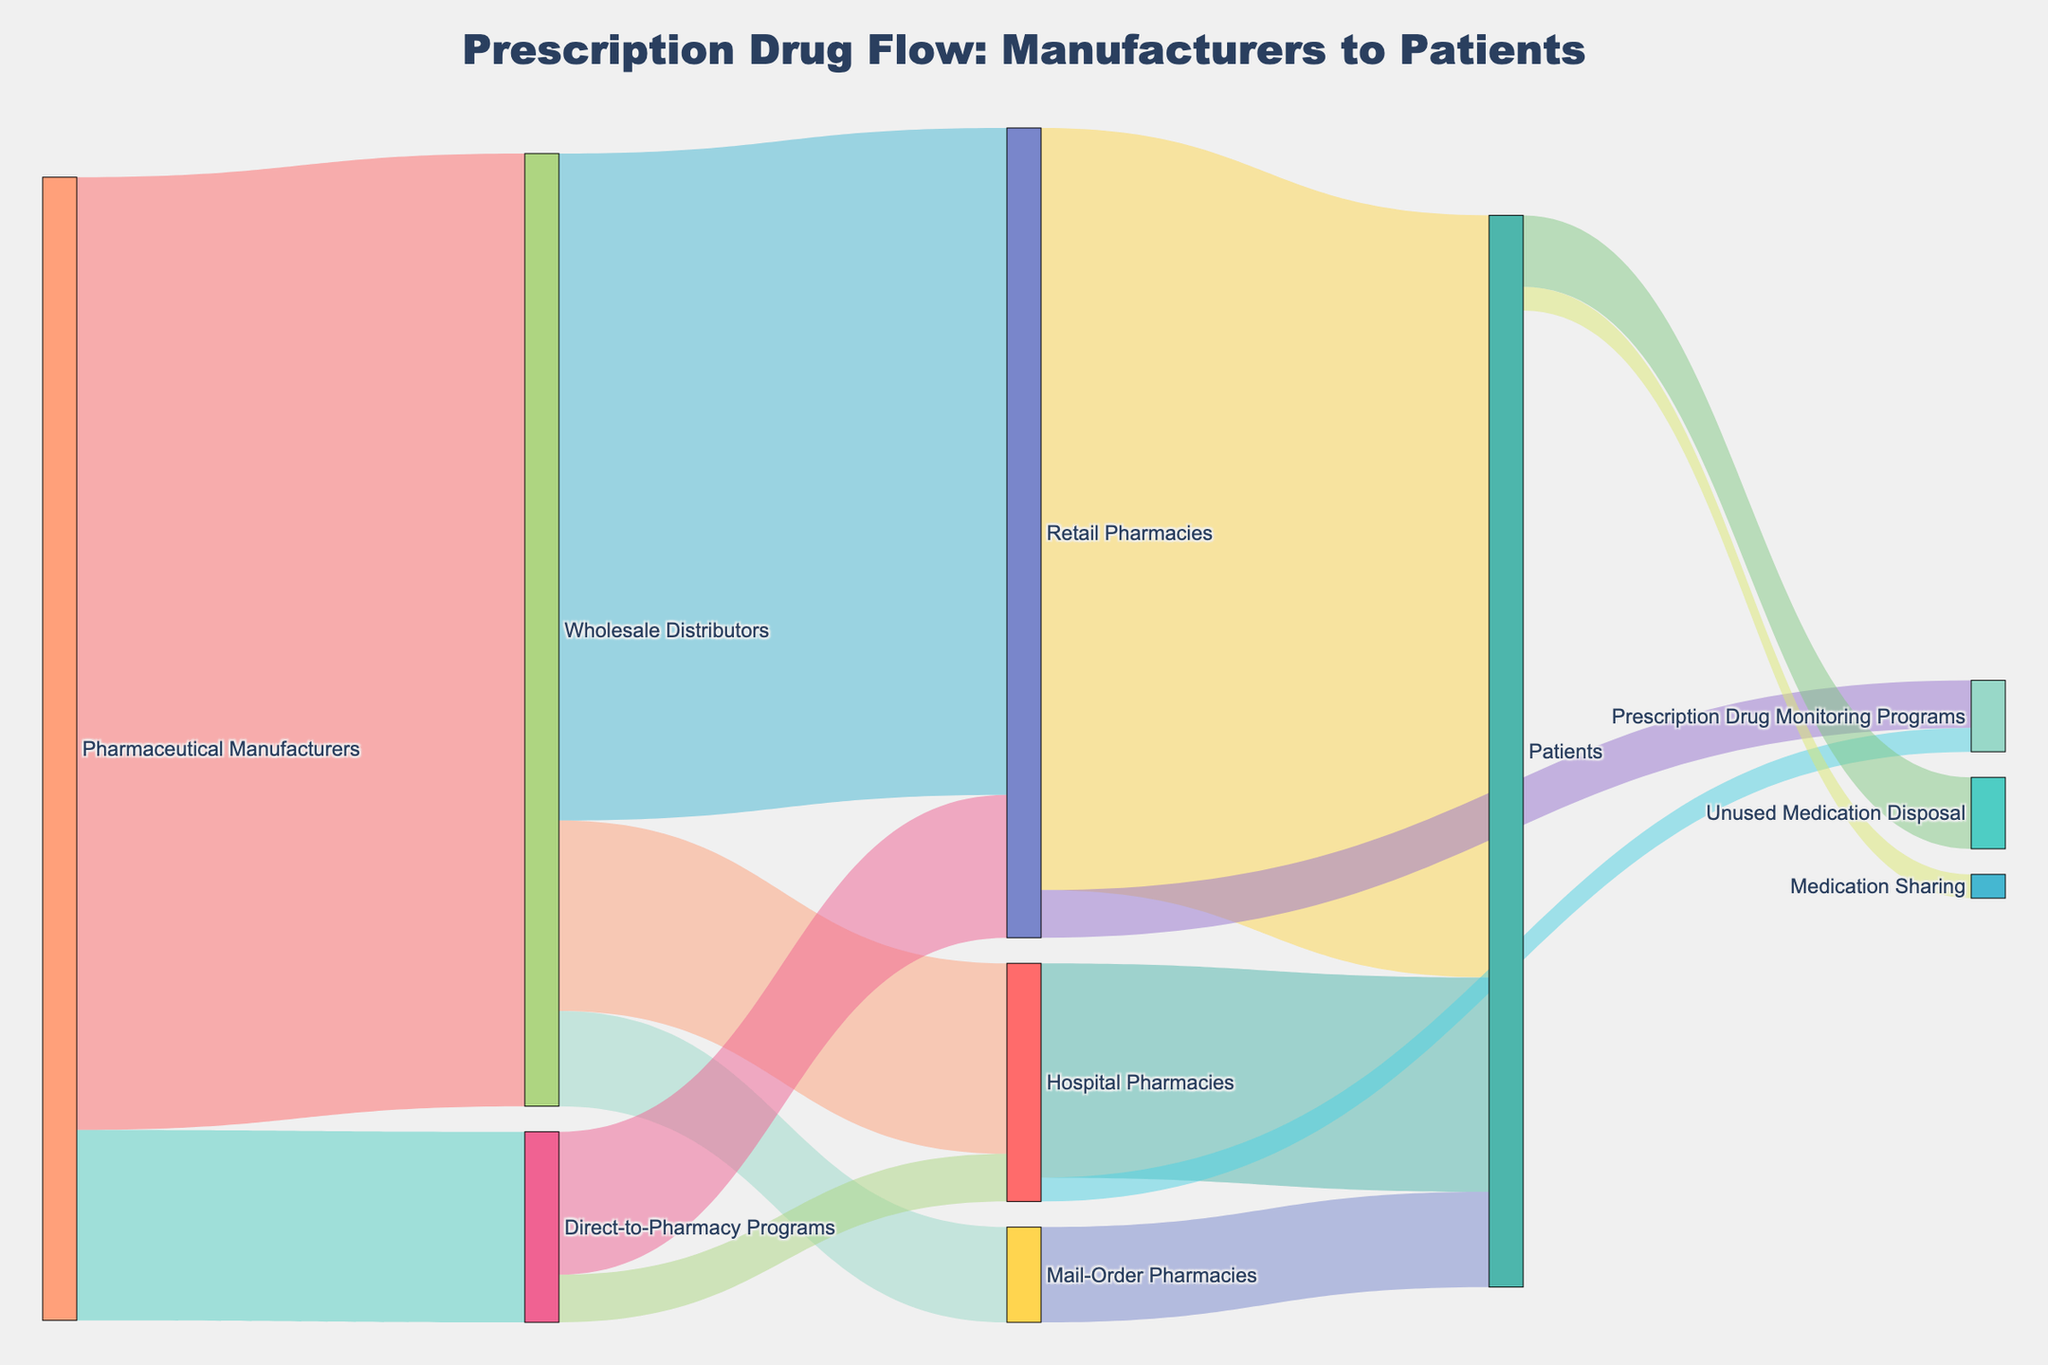What is the title of the figure? The title is located at the top center of the figure. It reads "Prescription Drug Flow: Manufacturers to Patients".
Answer: Prescription Drug Flow: Manufacturers to Patients Which distribution channel receives the largest amount of prescription drugs from wholesale distributors? The width of the flows in Sankey diagrams represents the quantity. The largest flow from wholesale distributors goes to retail pharmacies.
Answer: Retail Pharmacies How many distribution channels receive prescription drugs directly from pharmaceutical manufacturers? By counting the flows originating from "Pharmaceutical Manufacturers" to different targets, we find flows to "Wholesale Distributors" and "Direct-to-Pharmacy Programs". That's 2 channels.
Answer: 2 What is the total amount of prescription drugs that reach hospital pharmacies from all sources? The value to hospital pharmacies from wholesale distributors is 200 and from direct-to-pharmacy programs is 50. Summing them gives 200 + 50 = 250.
Answer: 250 How many units of prescription drugs are passed to patients by hospital pharmacies compared to mail-order pharmacies? Hospital pharmacies deliver 225 units to patients, while mail-order pharmacies deliver 100 units. The hospital pharmacies deliver more.
Answer: Hospital pharmacies deliver more Which intermediary has the smallest outflow of prescription drugs to patients? Looking at the width of the flows to patients from "Retail Pharmacies", "Hospital Pharmacies", and "Mail-Order Pharmacies", the smallest flow is from "Mail-Order Pharmacies" at 100.
Answer: Mail-Order Pharmacies What fraction of the prescription drugs routed to hospital pharmacies is directed to patients? Hospital pharmacies receive 200 (from wholesale distributors) + 50 (from direct-to-pharmacy programs) = 250. They direct 225 to patients, so the fraction is 225/250.
Answer: 225/250 How much prescription medication is disposed of as unused medication by patients? The flow labeled "Patients" to "Unused Medication Disposal" represents this amount, which is shown as 75.
Answer: 75 What is the share of prescription drugs handled by retail pharmacies compared to the total amount initially given to wholesale distributors by manufacturers? Retail pharmacies get 700 directly from wholesale distributors and 150 from direct-to-pharmacy programs, making a total of 850. Wholesale distributors initially handle 1000 units. The share is 850 / 1000.
Answer: 850/1000 How many units of medication do patients end up sharing, and what percentage of their total receipt is this? Patients share 25 units. They receive 800 (from retail pharmacies), 225 (from hospital), and 100 (from mail-order), totaling 1125. The percentage is (25 / 1125) * 100.
Answer: 2.22% 